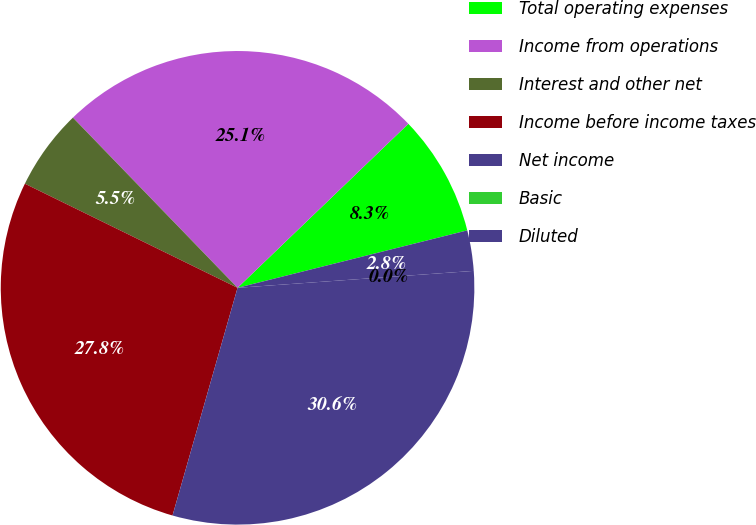Convert chart. <chart><loc_0><loc_0><loc_500><loc_500><pie_chart><fcel>Total operating expenses<fcel>Income from operations<fcel>Interest and other net<fcel>Income before income taxes<fcel>Net income<fcel>Basic<fcel>Diluted<nl><fcel>8.28%<fcel>25.06%<fcel>5.52%<fcel>27.82%<fcel>30.57%<fcel>0.0%<fcel>2.76%<nl></chart> 